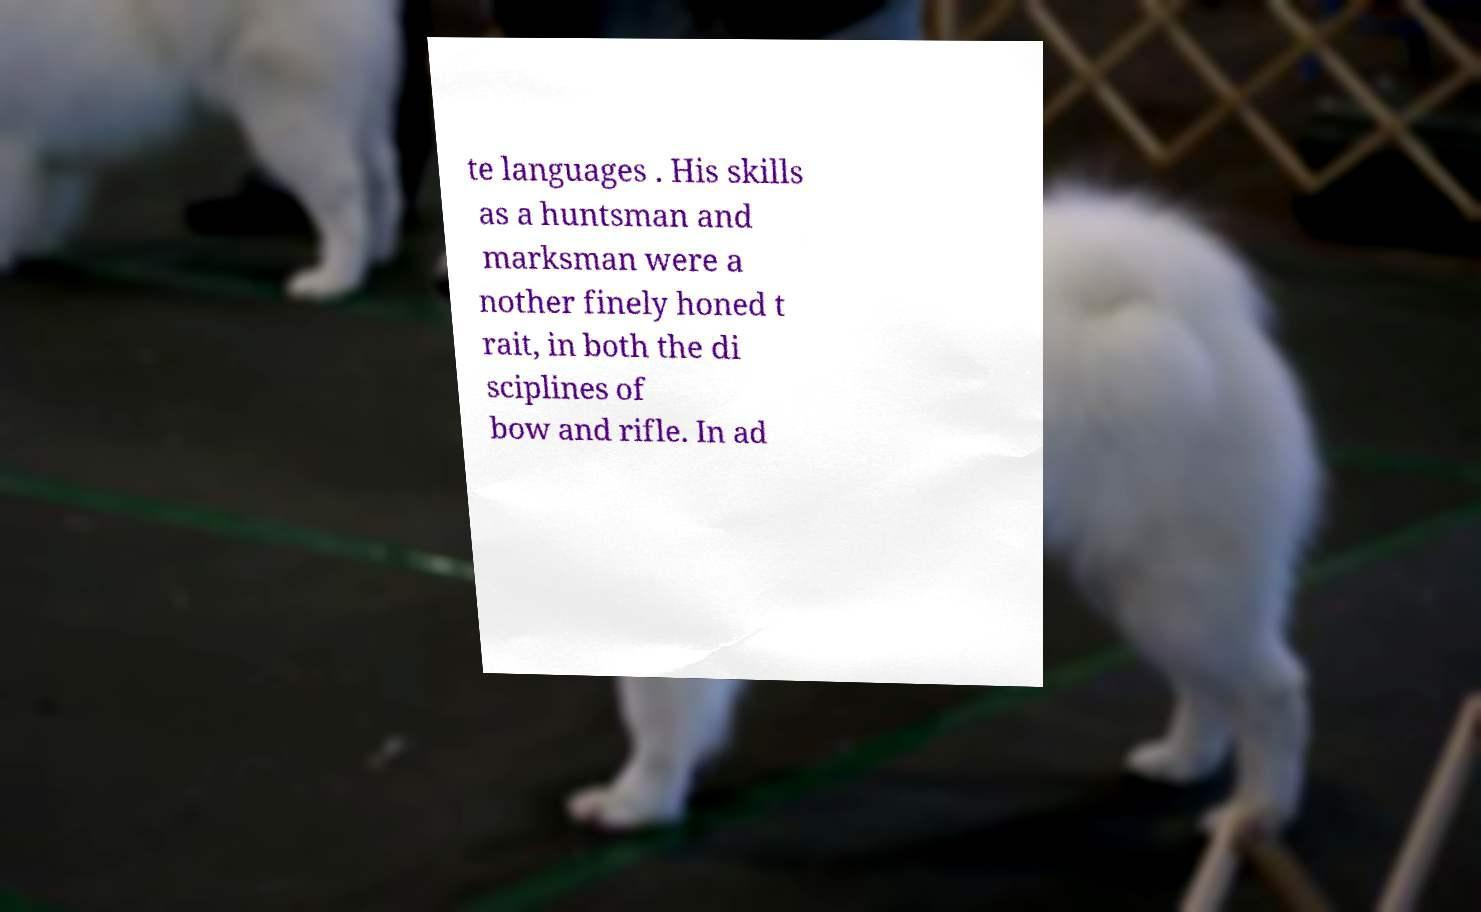What messages or text are displayed in this image? I need them in a readable, typed format. te languages . His skills as a huntsman and marksman were a nother finely honed t rait, in both the di sciplines of bow and rifle. In ad 